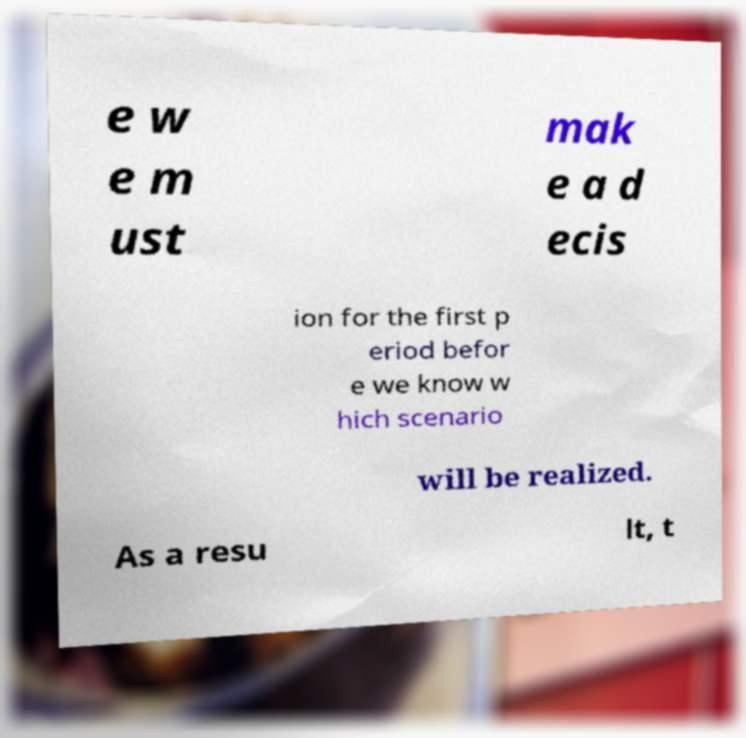For documentation purposes, I need the text within this image transcribed. Could you provide that? e w e m ust mak e a d ecis ion for the first p eriod befor e we know w hich scenario will be realized. As a resu lt, t 